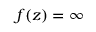Convert formula to latex. <formula><loc_0><loc_0><loc_500><loc_500>f ( z ) = \infty</formula> 